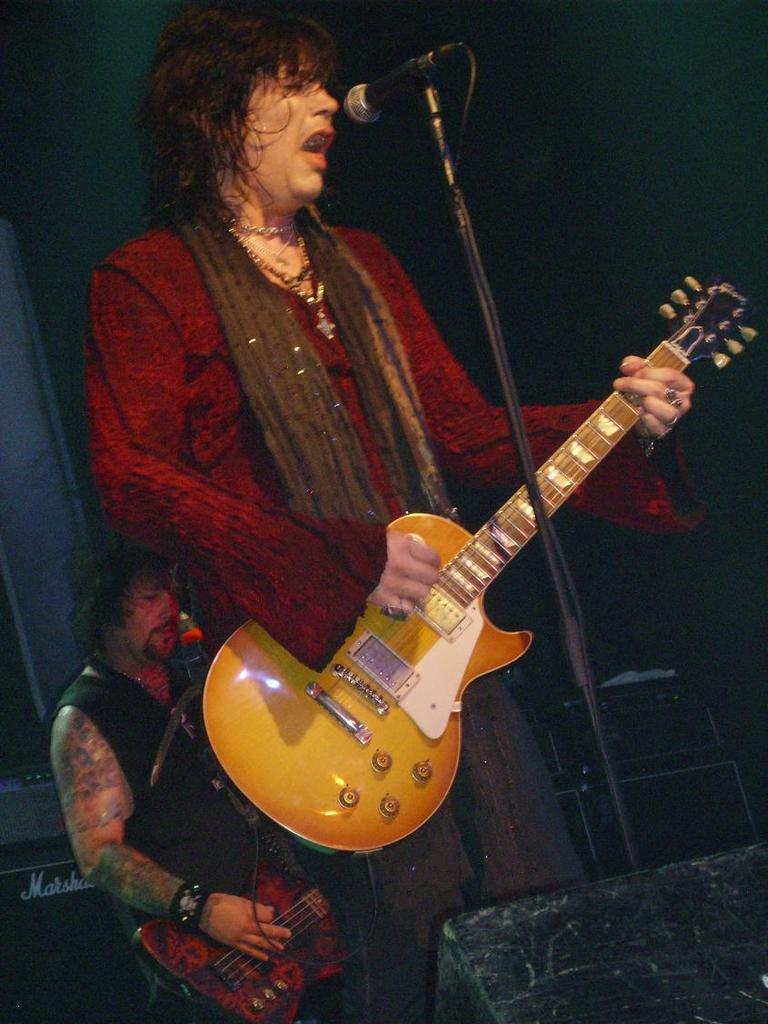How many people are in the image? There are two persons in the image. What are the two persons doing? The two persons are playing guitar. Can you identify any equipment related to music in the image? Yes, there is a microphone in the image. What type of meat is being cooked on the grill in the image? There is no grill or meat present in the image; it features two persons playing guitar and a microphone. What riddle can be solved by looking at the image? There is no riddle present in the image; it simply shows two people playing guitar and a microphone. 